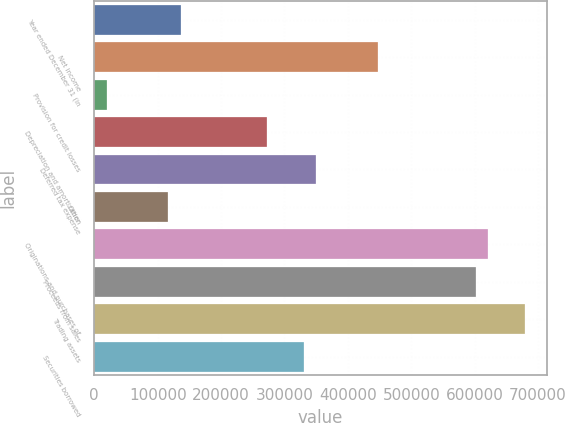Convert chart to OTSL. <chart><loc_0><loc_0><loc_500><loc_500><bar_chart><fcel>Year ended December 31 (in<fcel>Net income<fcel>Provision for credit losses<fcel>Depreciation and amortization<fcel>Deferred tax expense<fcel>Other<fcel>Originations and purchases of<fcel>Proceeds from sales<fcel>Trading assets<fcel>Securities borrowed<nl><fcel>136111<fcel>446789<fcel>19606.4<fcel>272033<fcel>349702<fcel>116693<fcel>621546<fcel>602128<fcel>679798<fcel>330285<nl></chart> 